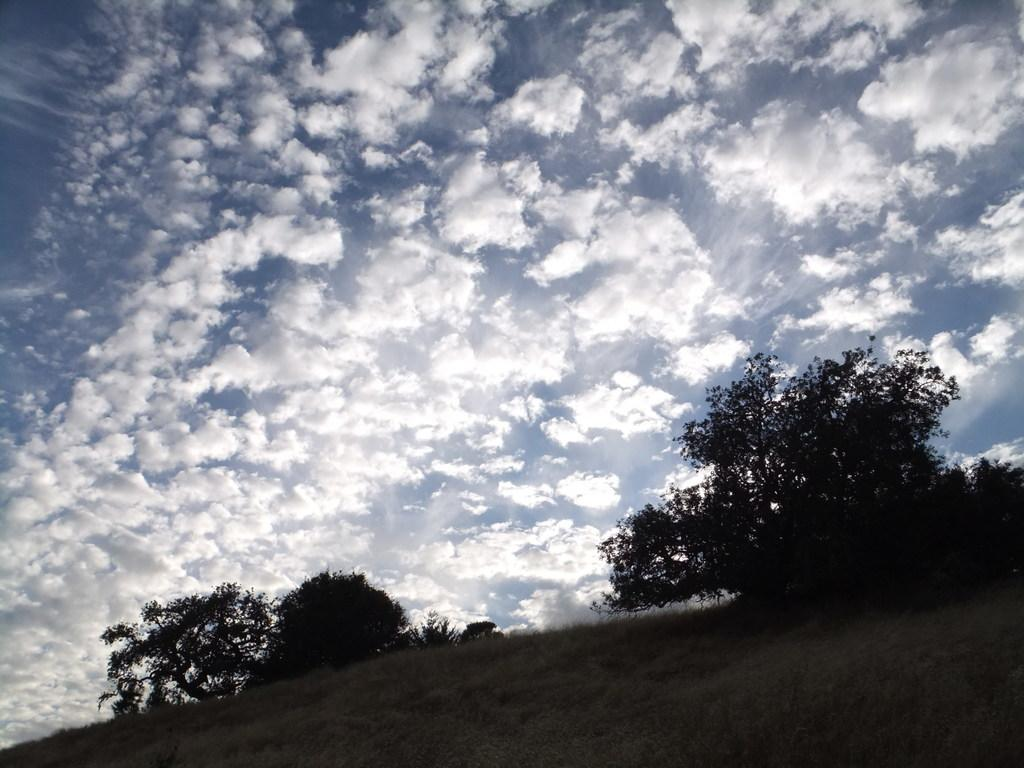What type of vegetation is present at the bottom of the image? There is grass on the ground at the bottom of the image. What other natural elements can be seen in the image? There are trees in the image. What is visible at the top of the image? The sky is visible at the top of the image. What can be observed in the sky? Clouds are present in the sky. How many fowl are perched on the trees in the image? There are no fowl present in the image; it only features trees and clouds in the sky. What type of tool is being used by the boys in the image? There are no boys or tools present in the image; it only features grass, trees, and clouds in the sky. 